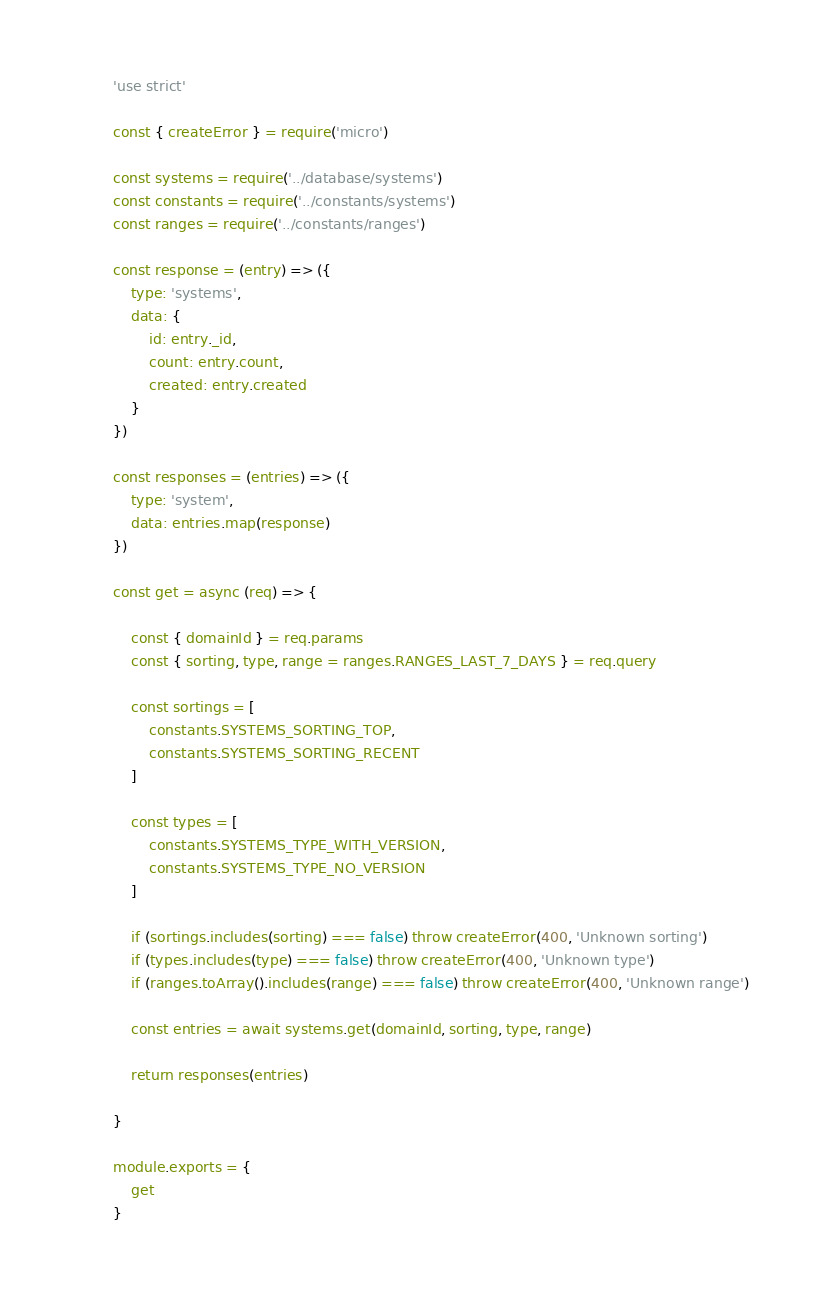Convert code to text. <code><loc_0><loc_0><loc_500><loc_500><_JavaScript_>'use strict'

const { createError } = require('micro')

const systems = require('../database/systems')
const constants = require('../constants/systems')
const ranges = require('../constants/ranges')

const response = (entry) => ({
	type: 'systems',
	data: {
		id: entry._id,
		count: entry.count,
		created: entry.created
	}
})

const responses = (entries) => ({
	type: 'system',
	data: entries.map(response)
})

const get = async (req) => {

	const { domainId } = req.params
	const { sorting, type, range = ranges.RANGES_LAST_7_DAYS } = req.query

	const sortings = [
		constants.SYSTEMS_SORTING_TOP,
		constants.SYSTEMS_SORTING_RECENT
	]

	const types = [
		constants.SYSTEMS_TYPE_WITH_VERSION,
		constants.SYSTEMS_TYPE_NO_VERSION
	]

	if (sortings.includes(sorting) === false) throw createError(400, 'Unknown sorting')
	if (types.includes(type) === false) throw createError(400, 'Unknown type')
	if (ranges.toArray().includes(range) === false) throw createError(400, 'Unknown range')

	const entries = await systems.get(domainId, sorting, type, range)

	return responses(entries)

}

module.exports = {
	get
}</code> 